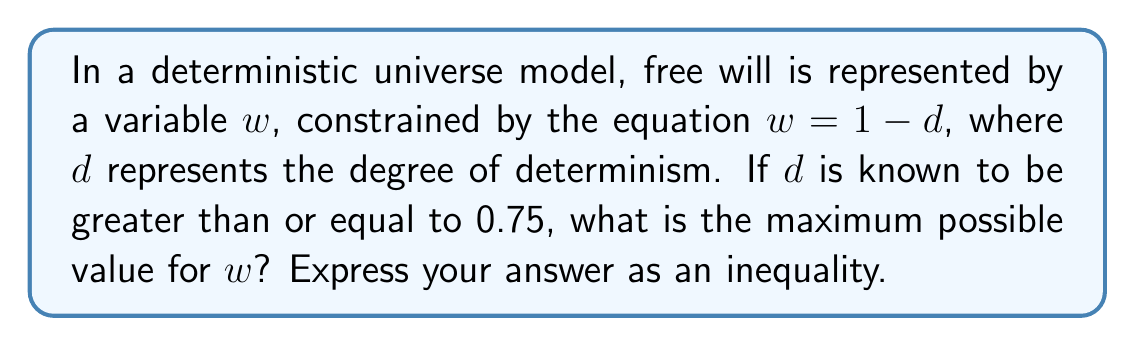Solve this math problem. To solve this problem, we need to follow these steps:

1) We are given that $w = 1 - d$, where $w$ represents free will and $d$ represents determinism.

2) We are also told that $d \geq 0.75$. This means that determinism is at least 75%.

3) To find the maximum possible value for $w$, we need to consider the lowest possible value for $d$, which is 0.75.

4) Substituting this into our equation:

   $w = 1 - d$
   $w = 1 - 0.75$
   $w = 0.25$

5) This means that the maximum value for $w$ is 0.25.

6) However, we need to express this as an inequality. Since $w$ can be equal to 0.25 but not greater than it, we use the $\leq$ symbol.

Therefore, the maximum possible value for $w$ can be expressed as: $w \leq 0.25$

This inequality represents the mathematical boundary of free will within this deterministic universe model.
Answer: $w \leq 0.25$ 